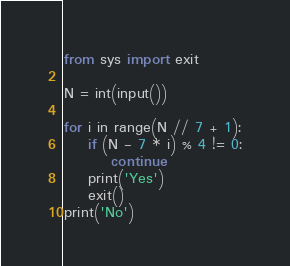Convert code to text. <code><loc_0><loc_0><loc_500><loc_500><_Python_>from sys import exit

N = int(input())

for i in range(N // 7 + 1):
    if (N - 7 * i) % 4 != 0:
        continue
    print('Yes')
    exit()
print('No')
</code> 